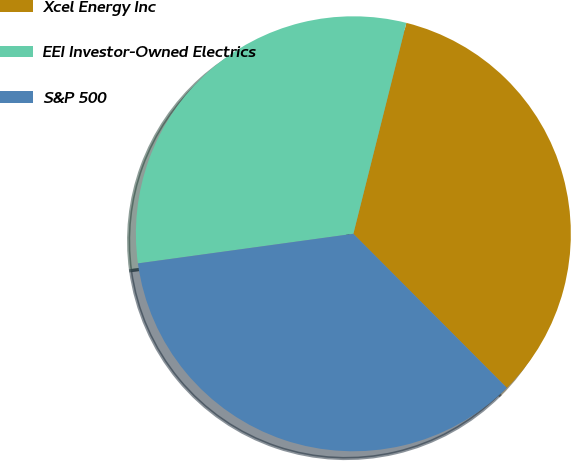Convert chart to OTSL. <chart><loc_0><loc_0><loc_500><loc_500><pie_chart><fcel>Xcel Energy Inc<fcel>EEI Investor-Owned Electrics<fcel>S&P 500<nl><fcel>33.61%<fcel>31.09%<fcel>35.29%<nl></chart> 